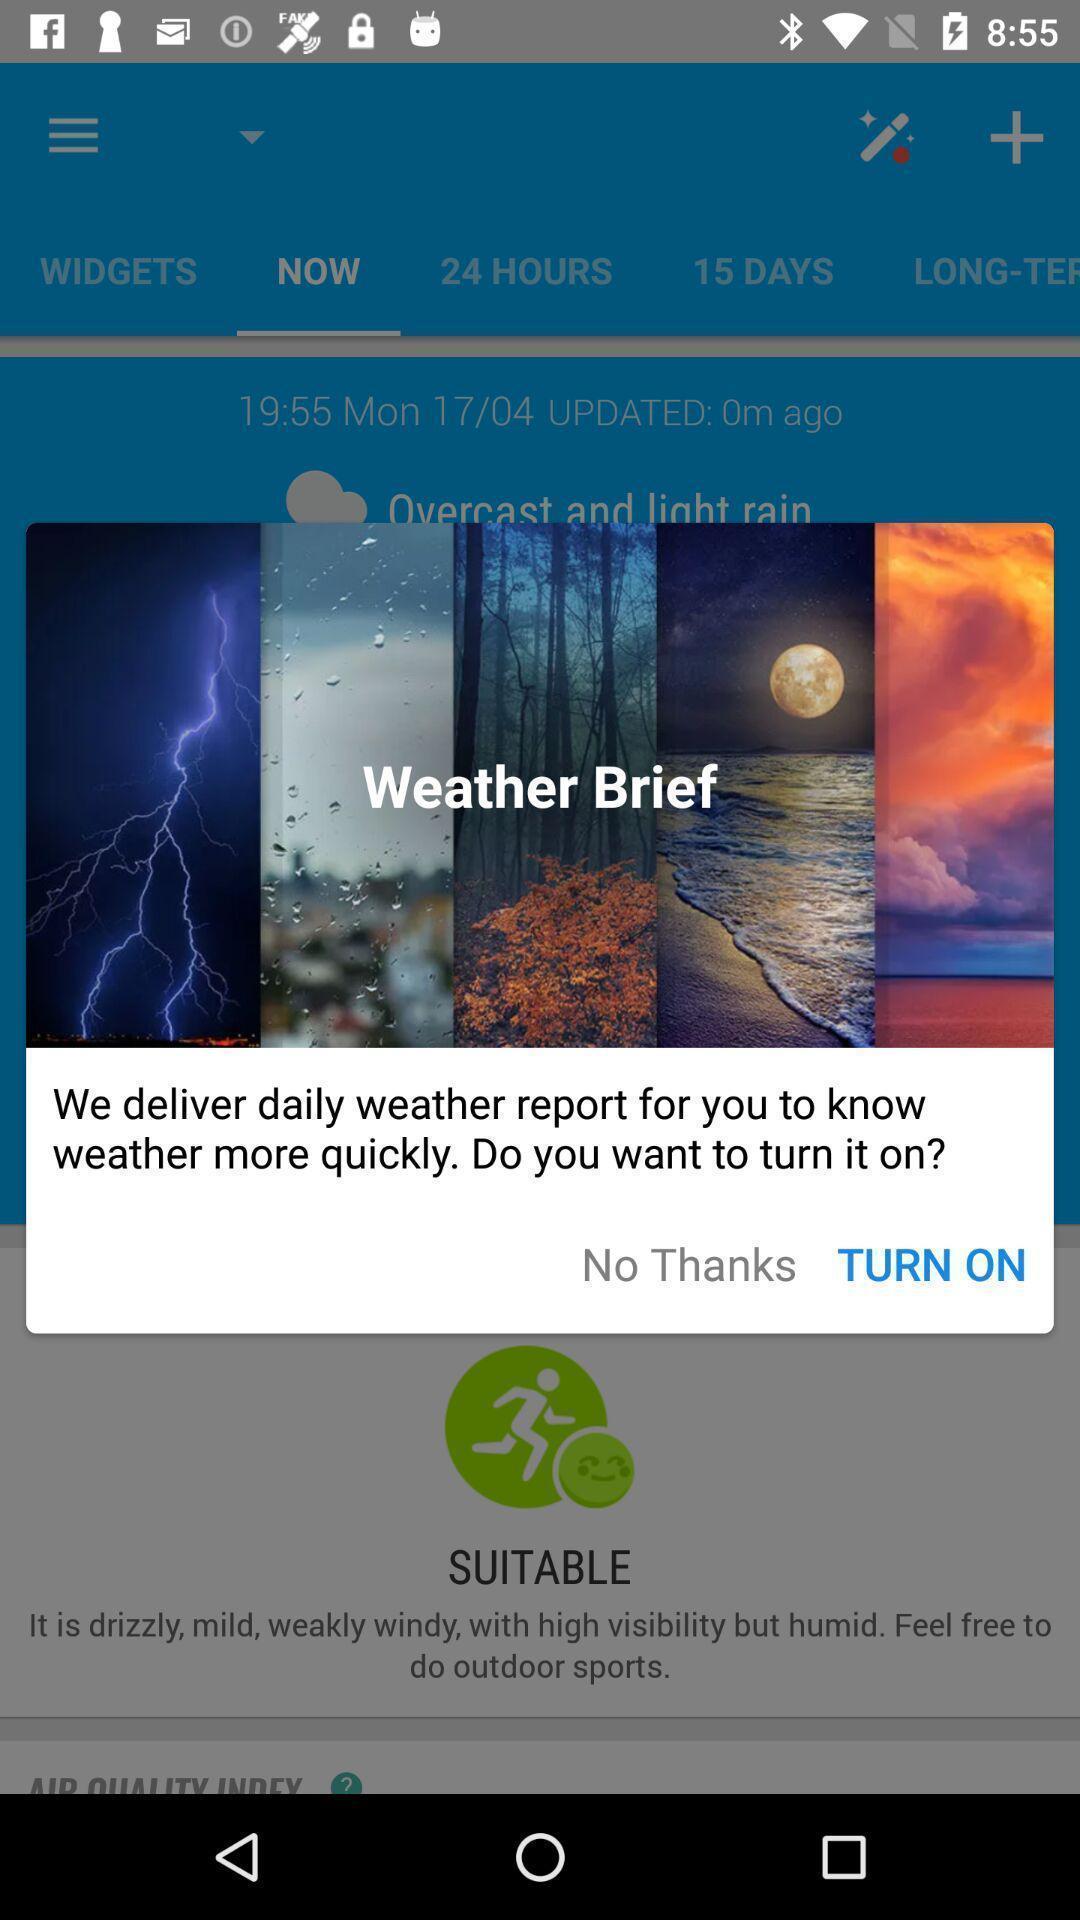Provide a textual representation of this image. Pop up to turn on notification. 